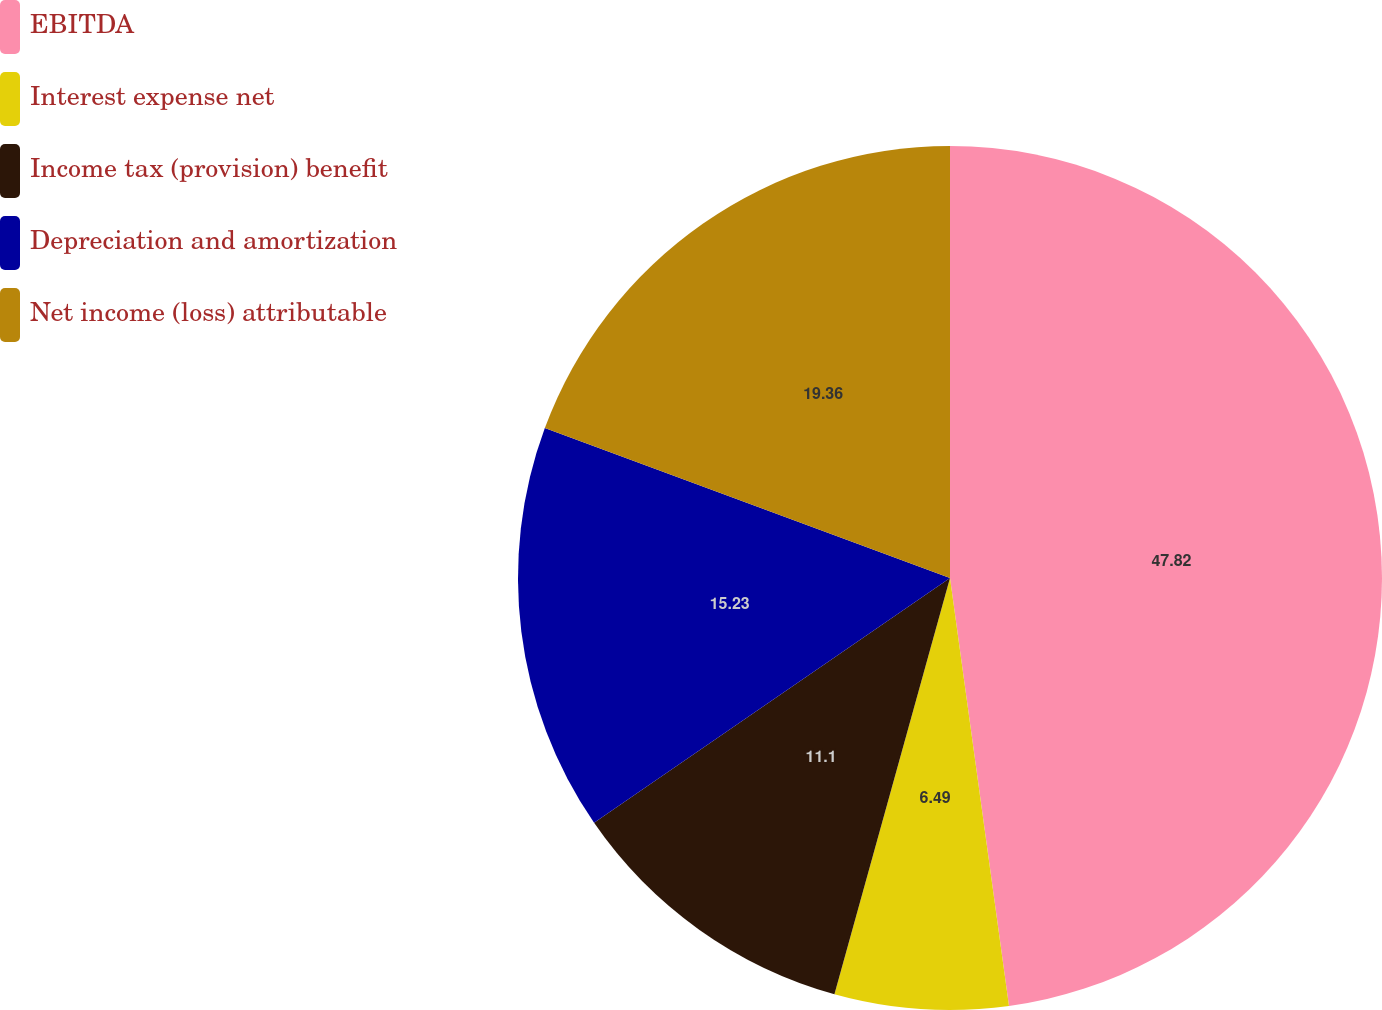<chart> <loc_0><loc_0><loc_500><loc_500><pie_chart><fcel>EBITDA<fcel>Interest expense net<fcel>Income tax (provision) benefit<fcel>Depreciation and amortization<fcel>Net income (loss) attributable<nl><fcel>47.82%<fcel>6.49%<fcel>11.1%<fcel>15.23%<fcel>19.36%<nl></chart> 